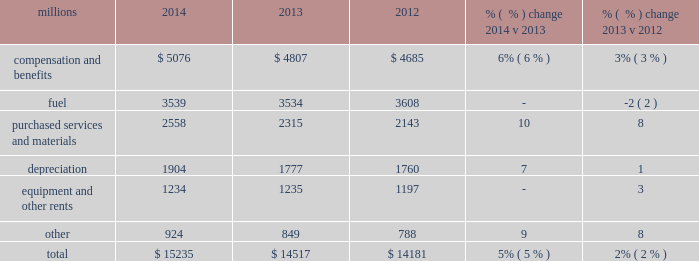Operating expenses millions 2014 2013 2012 % (  % ) change 2014 v 2013 % (  % ) change 2013 v 2012 .
Operating expenses increased $ 718 million in 2014 versus 2013 .
Volume-related expenses , incremental costs associated with operating a slower network , depreciation , wage and benefit inflation , and locomotive and freight car materials contributed to the higher costs .
Lower fuel price partially offset these increases .
In addition , there were approximately $ 35 million of weather related costs in the first quarter of operating expenses increased $ 336 million in 2013 versus 2012 .
Wage and benefit inflation , new logistics management fees and container costs for our automotive business , locomotive overhauls , property taxes and repairs on jointly owned property contributed to higher expenses during the year .
Lower fuel prices partially offset the cost increases .
Compensation and benefits 2013 compensation and benefits include wages , payroll taxes , health and welfare costs , pension costs , other postretirement benefits , and incentive costs .
Volume-related expenses , including training , and a slower network increased our train and engine work force , which , along with general wage and benefit inflation , drove increased wages .
Weather-related costs in the first quarter of 2014 also increased costs .
General wages and benefits inflation , including increased pension and other postretirement benefits , and higher work force levels drove the increases in 2013 versus 2012 .
The impact of ongoing productivity initiatives partially offset these increases .
Fuel 2013 fuel includes locomotive fuel and gasoline for highway and non-highway vehicles and heavy equipment .
Volume growth of 7% ( 7 % ) , as measured by gross ton-miles , drove the increase in fuel expense .
This was essentially offset by lower locomotive diesel fuel prices , which averaged $ 2.97 per gallon ( including taxes and transportation costs ) in 2014 , compared to $ 3.15 in 2013 , along with a slight improvement in fuel consumption rate , computed as gallons of fuel consumed divided by gross ton-miles .
Lower locomotive diesel fuel prices , which averaged $ 3.15 per gallon ( including taxes and transportation costs ) in 2013 , compared to $ 3.22 in 2012 , decreased expenses by $ 75 million .
Volume , as measured by gross ton-miles , decreased 1% ( 1 % ) while the fuel consumption rate , computed as gallons of fuel consumed divided by gross ton-miles , increased 2% ( 2 % ) compared to 2012 .
Declines in heavier , more fuel-efficient coal shipments drove the variances in gross-ton-miles and the fuel consumption rate .
Purchased services and materials 2013 expense for purchased services and materials includes the costs of services purchased from outside contractors and other service providers ( including equipment maintenance and contract expenses incurred by our subsidiaries for external transportation services ) ; materials used to maintain the railroad 2019s lines , structures , and equipment ; costs of operating facilities jointly used by uprr and other railroads ; transportation and lodging for train crew employees ; trucking and contracting costs for intermodal containers ; leased automobile maintenance expenses ; and tools and supplies .
Expenses for purchased services increased 8% ( 8 % ) compared to 2013 primarily due to volume- 2014 operating expenses .
Non cash expense are what percent of total operating expense in 2014? 
Rationale: depreciation - non cash
Computations: (1904 / 15235)
Answer: 0.12498. 